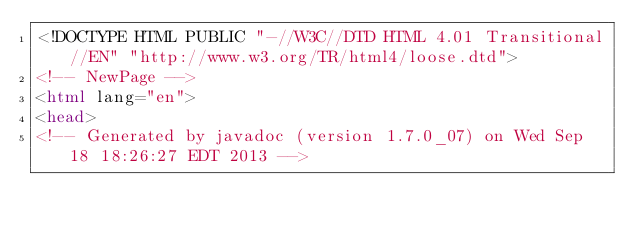Convert code to text. <code><loc_0><loc_0><loc_500><loc_500><_HTML_><!DOCTYPE HTML PUBLIC "-//W3C//DTD HTML 4.01 Transitional//EN" "http://www.w3.org/TR/html4/loose.dtd">
<!-- NewPage -->
<html lang="en">
<head>
<!-- Generated by javadoc (version 1.7.0_07) on Wed Sep 18 18:26:27 EDT 2013 --></code> 